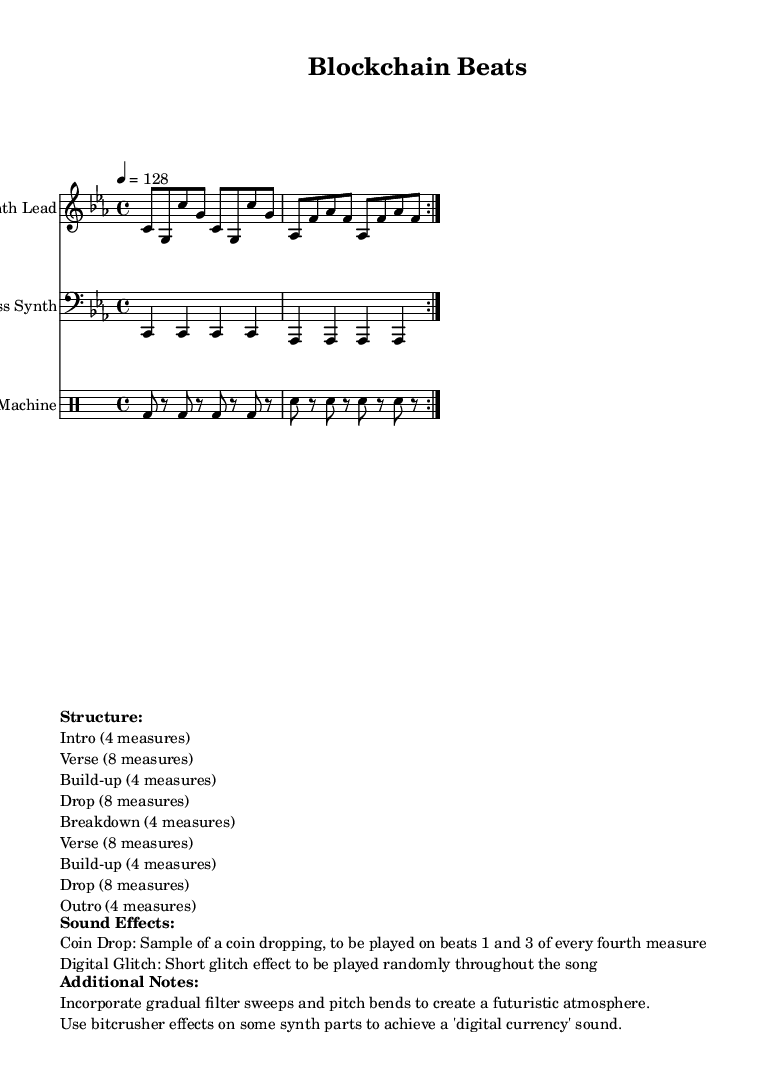What is the key signature of this music? The key signature is presented in the global section of the code, which indicates C minor, as specified by the command "\key c \minor".
Answer: C minor What is the time signature of this music? The time signature is given in the global section as well, where it states "\time 4/4", indicating four beats per measure with the quarter note getting one beat.
Answer: 4/4 What is the tempo of this music? The tempo is specified in the global section of the code, marked as "\tempo 4 = 128", indicating a tempo of 128 beats per minute.
Answer: 128 How many measures are there in the verse section? From the markup section detailing the structure, the verse is stated to be eight measures long, confirming the count directly mentioned.
Answer: 8 measures What sound effect is used for the coin drop? The sound effect for the "coin drop" is described in the markup section, where it explicitly notes this effect to be a sample of a coin dropping, played on specific beats.
Answer: Sample of a coin dropping What structure does the music follow after the drop? Referring to the structure outlined in the markup, the sequence reveals that after the drop, the music transitions into a breakdown, followed by another verse, then a build-up, and again a drop.
Answer: Breakdown 